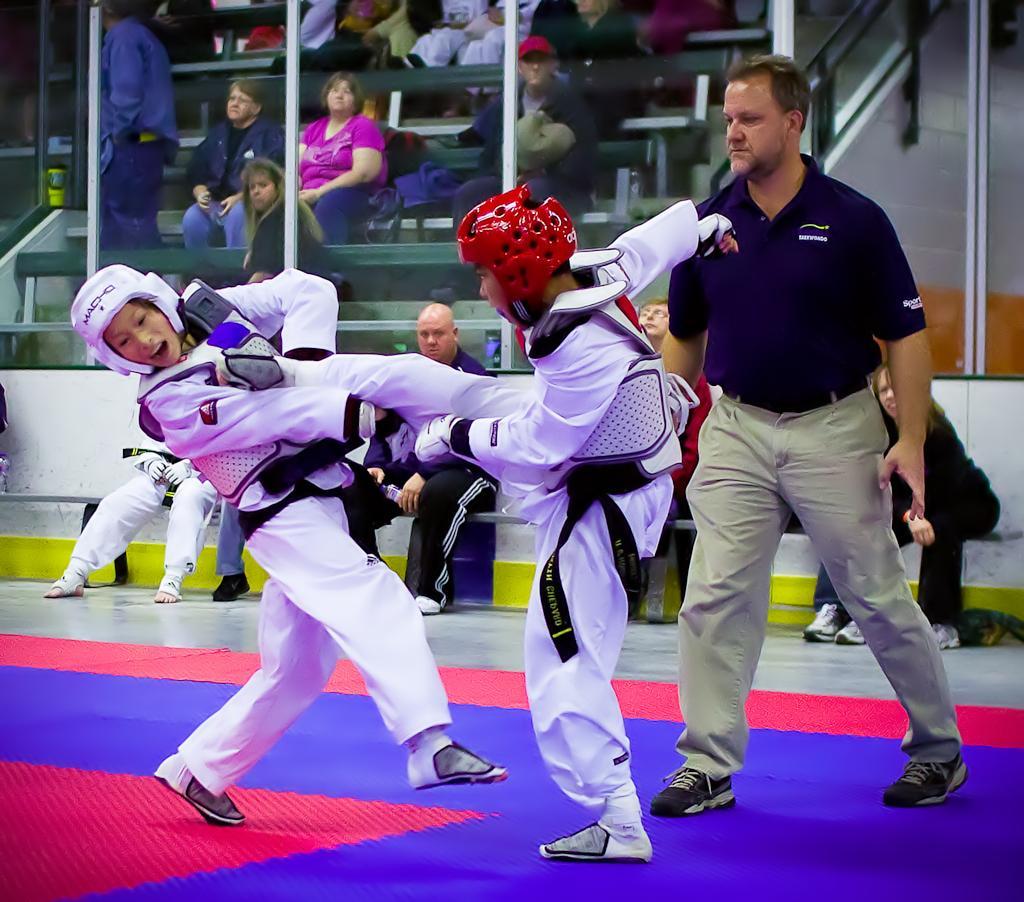In one or two sentences, can you explain what this image depicts? In the foreground of this image, there are two boys in white dress wearing helmets are performing karate on the floor. Behind them, there is a man standing. In the background, there are persons sitting on the benches in front of a glass and few are sitting on the benches behind the glass. 